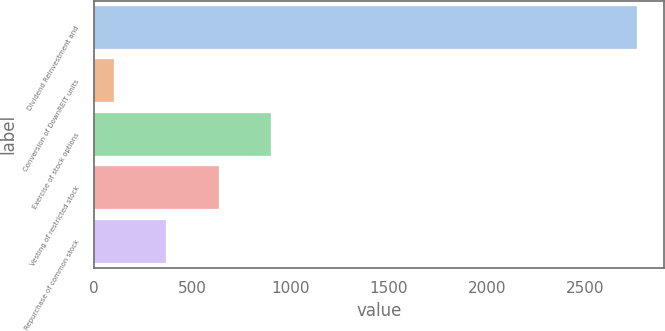Convert chart. <chart><loc_0><loc_0><loc_500><loc_500><bar_chart><fcel>Dividend Reinvestment and<fcel>Conversion of DownREIT units<fcel>Exercise of stock options<fcel>Vesting of restricted stock<fcel>Repurchase of common stock<nl><fcel>2762<fcel>104<fcel>901.4<fcel>635.6<fcel>369.8<nl></chart> 